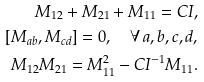<formula> <loc_0><loc_0><loc_500><loc_500>M _ { 1 2 } + M _ { 2 1 } + M _ { 1 1 } = C I , \\ [ M _ { a b } , M _ { c d } ] = 0 , \quad \forall \, a , b , c , d , \\ M _ { 1 2 } M _ { 2 1 } = M _ { 1 1 } ^ { 2 } - C I ^ { - 1 } M _ { 1 1 } .</formula> 